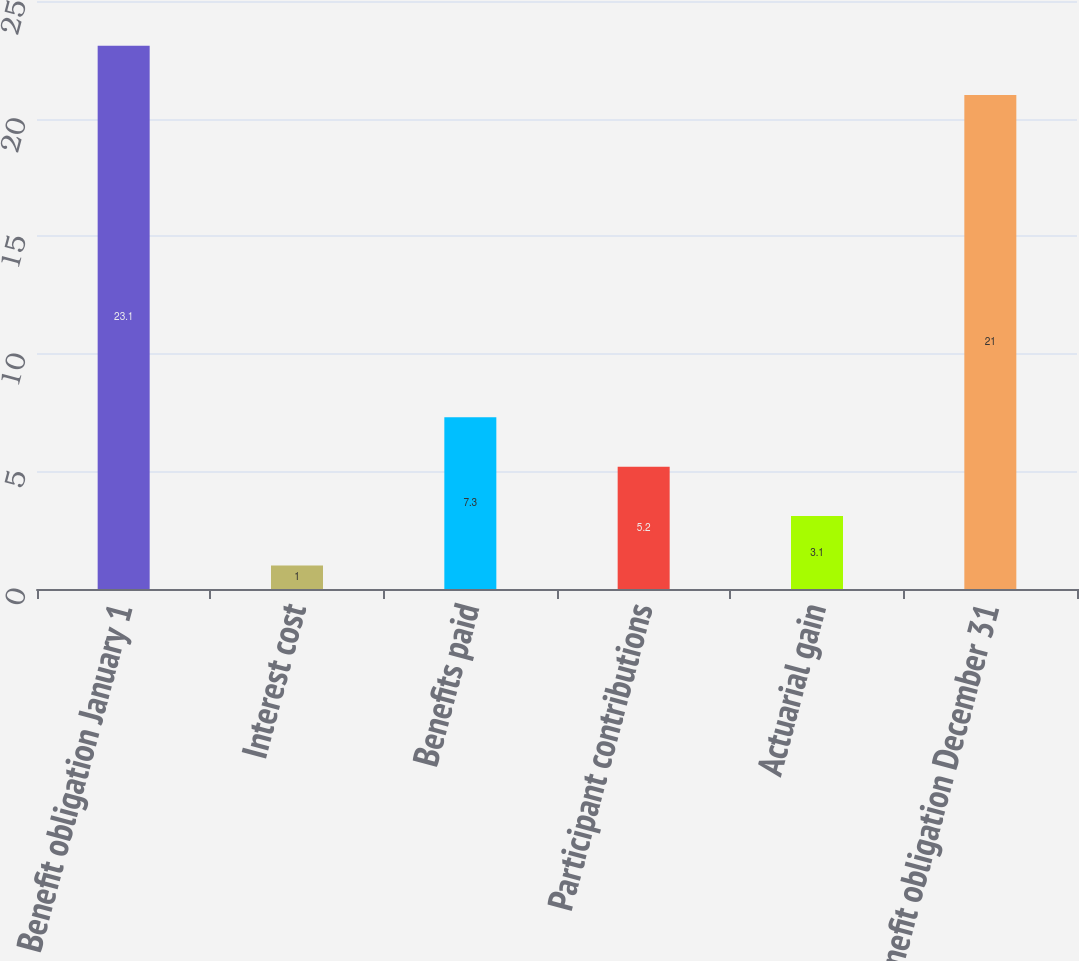Convert chart to OTSL. <chart><loc_0><loc_0><loc_500><loc_500><bar_chart><fcel>Benefit obligation January 1<fcel>Interest cost<fcel>Benefits paid<fcel>Participant contributions<fcel>Actuarial gain<fcel>Benefit obligation December 31<nl><fcel>23.1<fcel>1<fcel>7.3<fcel>5.2<fcel>3.1<fcel>21<nl></chart> 